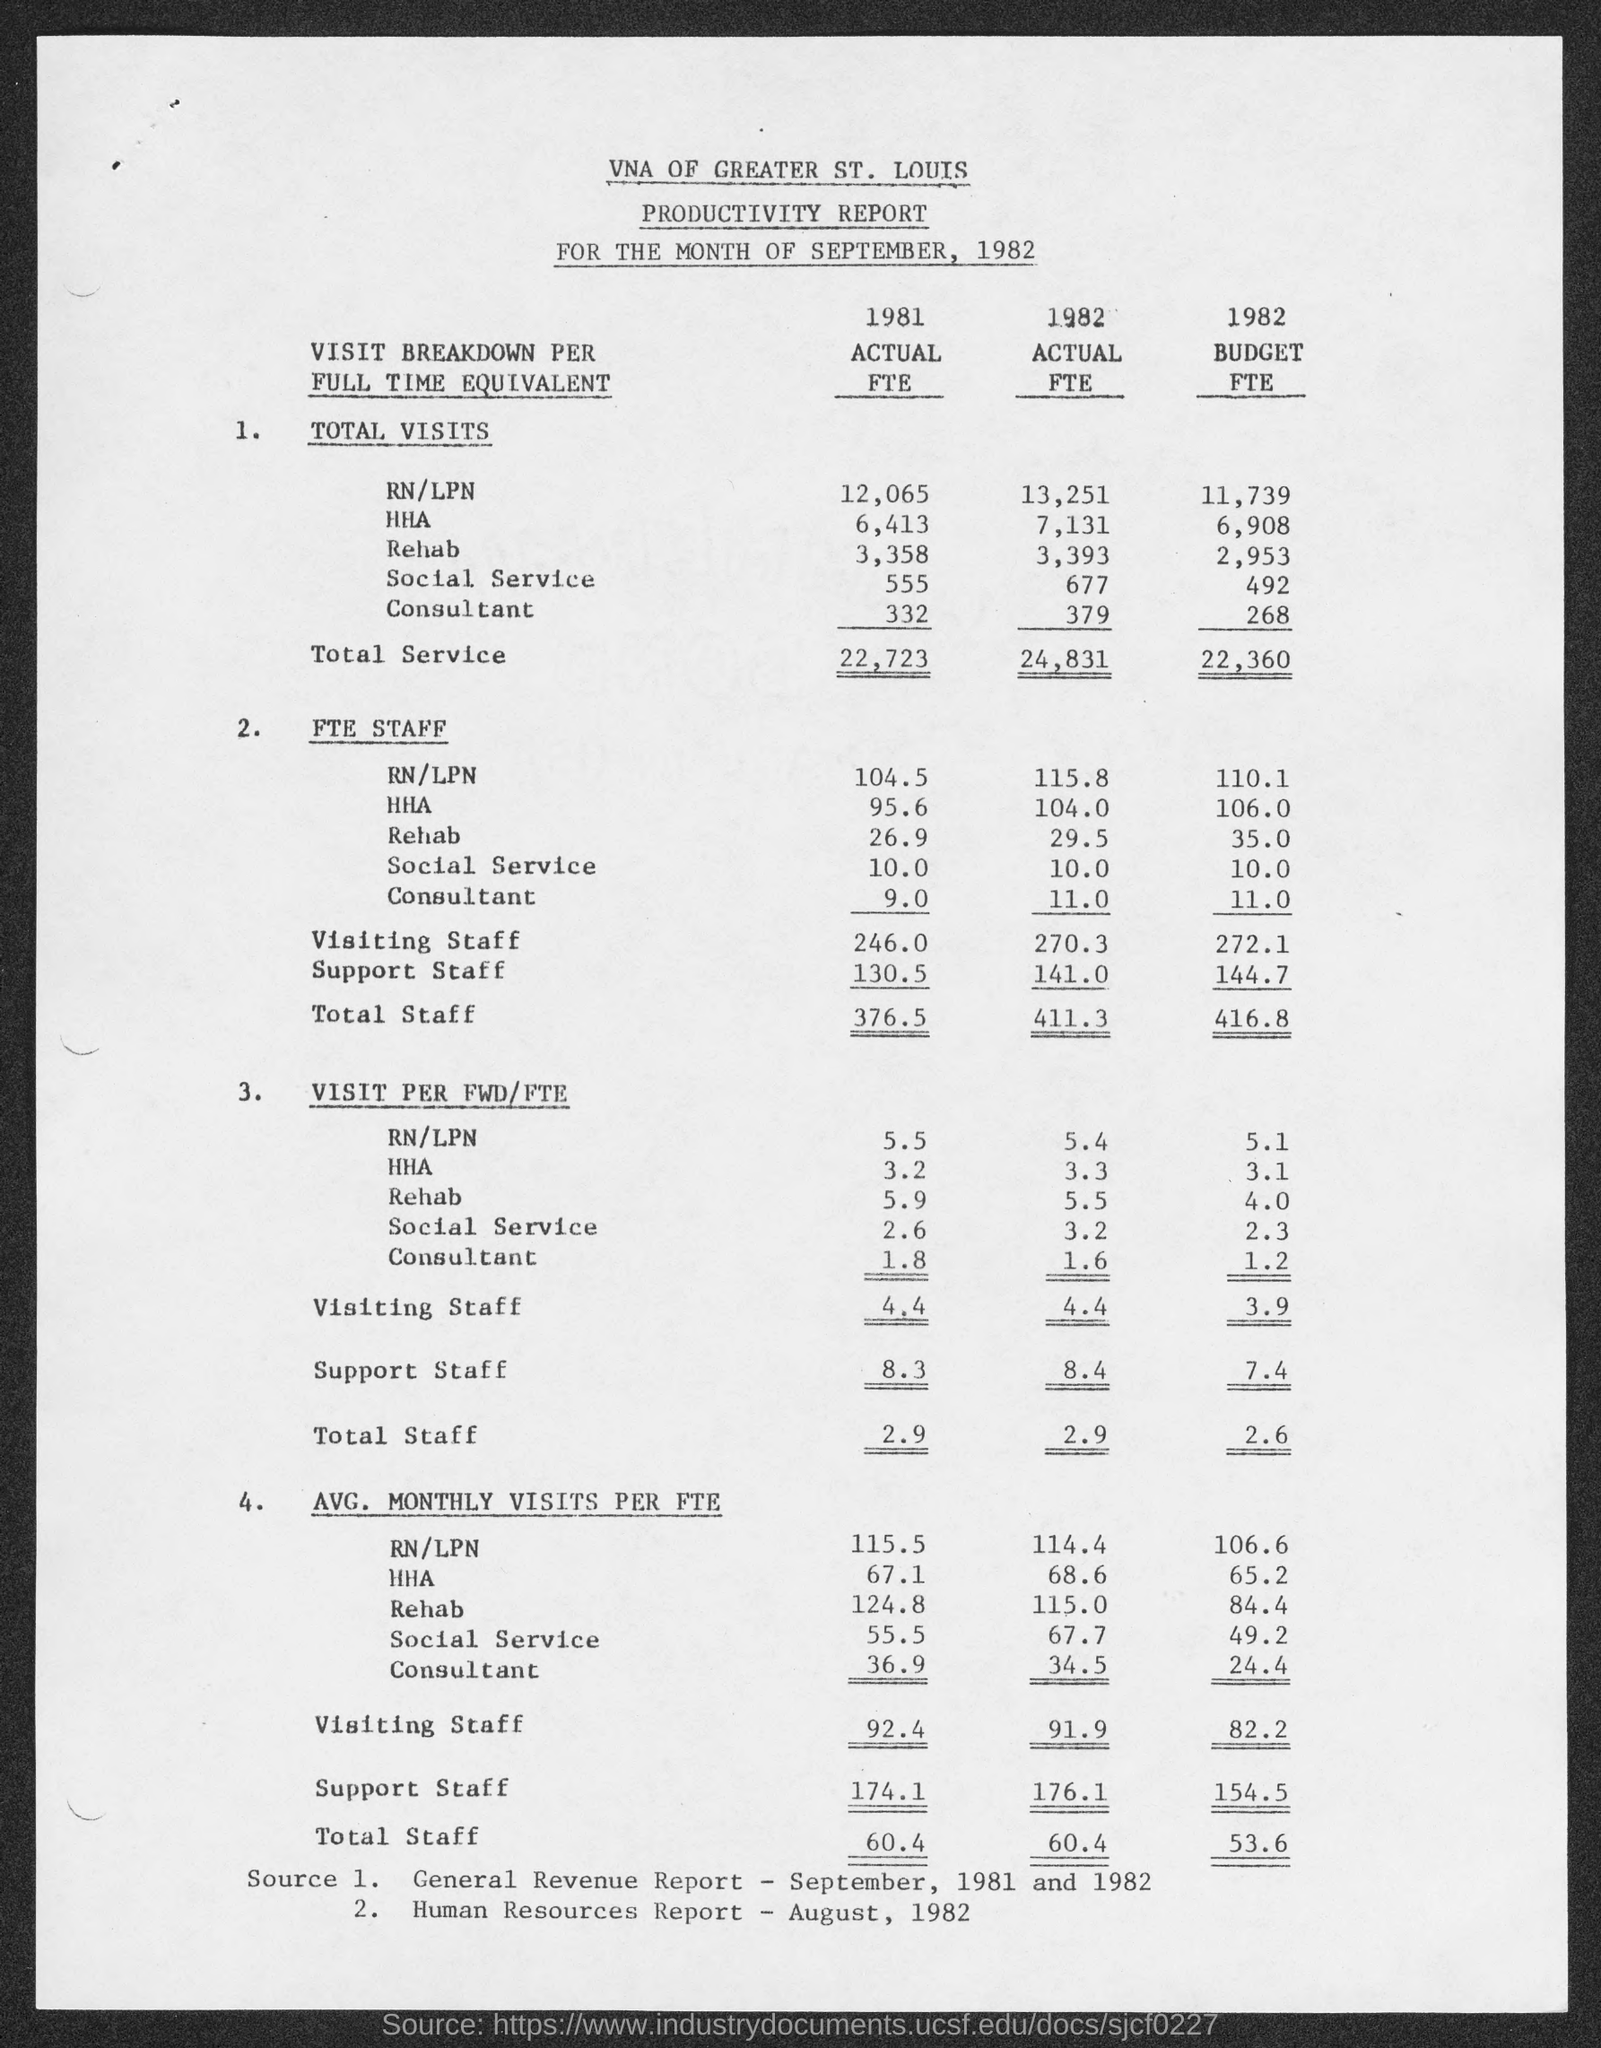Indicate a few pertinent items in this graphic. The total service in actual full-time equivalents in 1981 was 22,723. The total full-time equivalent (FTE) staff in 1982 was 411.3. 